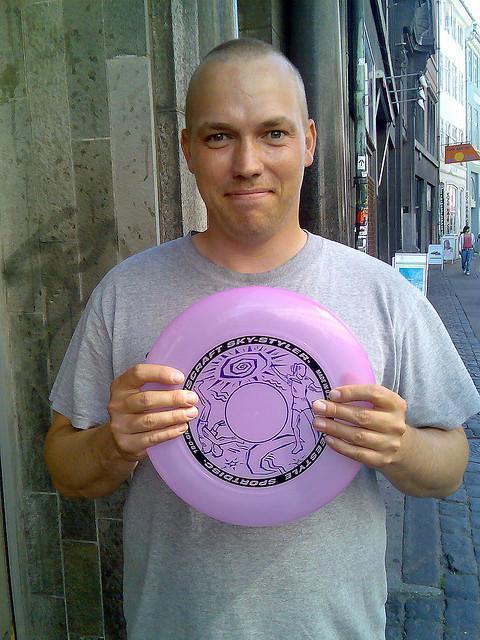How many elephants are in the grass?
Give a very brief answer. 0. 